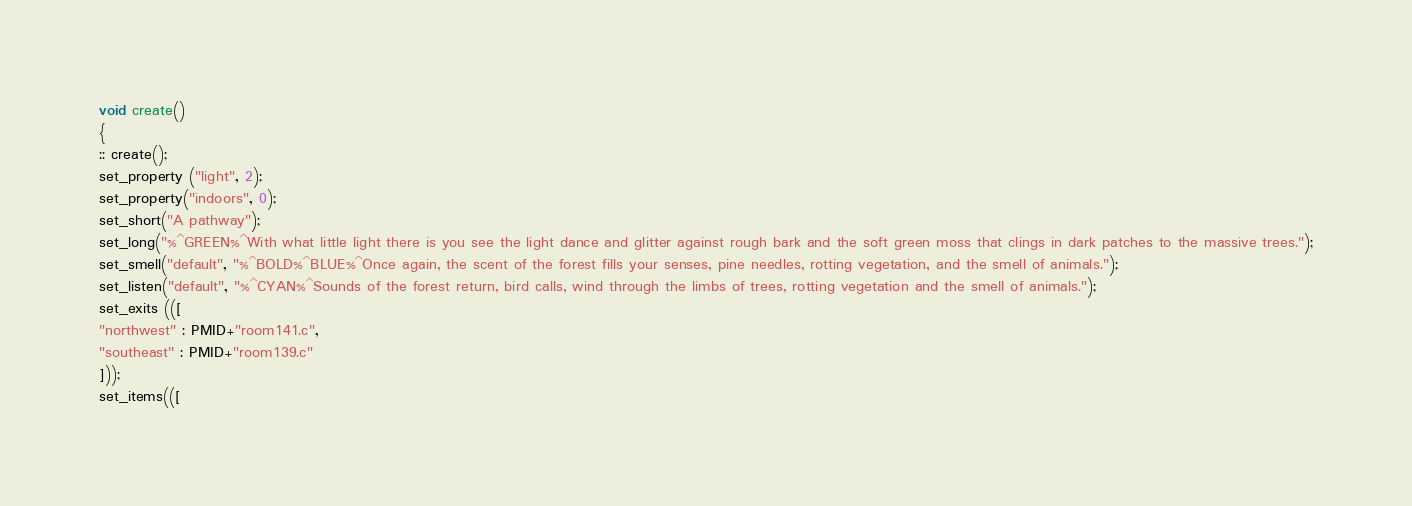<code> <loc_0><loc_0><loc_500><loc_500><_C_>void create()
{
:: create();
set_property ("light", 2);
set_property("indoors", 0);
set_short("A pathway");
set_long("%^GREEN%^With what little light there is you see the light dance and glitter against rough bark and the soft green moss that clings in dark patches to the massive trees.");
set_smell("default", "%^BOLD%^BLUE%^Once again, the scent of the forest fills your senses, pine needles, rotting vegetation, and the smell of animals.");
set_listen("default", "%^CYAN%^Sounds of the forest return, bird calls, wind through the limbs of trees, rotting vegetation and the smell of animals.");
set_exits (([
"northwest" : PMID+"room141.c",
"southeast" : PMID+"room139.c"
]));
set_items(([</code> 